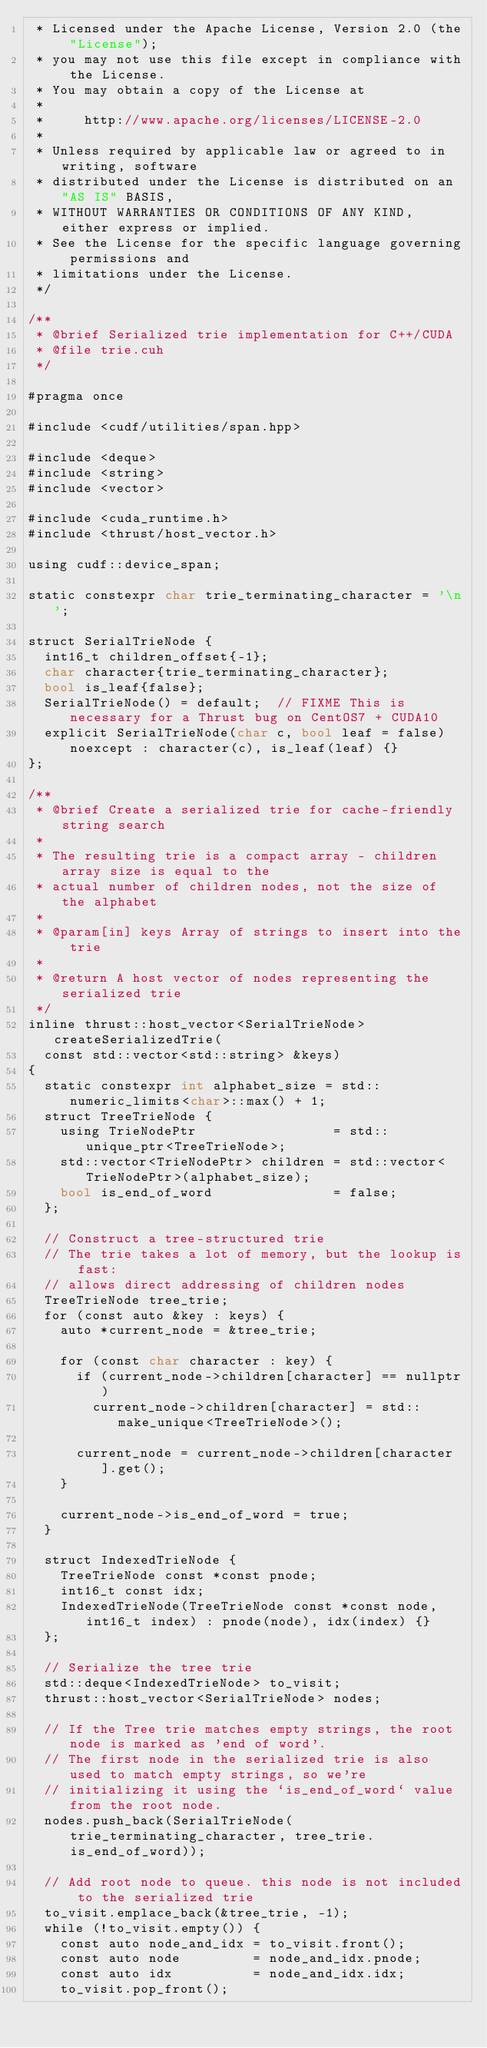Convert code to text. <code><loc_0><loc_0><loc_500><loc_500><_Cuda_> * Licensed under the Apache License, Version 2.0 (the "License");
 * you may not use this file except in compliance with the License.
 * You may obtain a copy of the License at
 *
 *     http://www.apache.org/licenses/LICENSE-2.0
 *
 * Unless required by applicable law or agreed to in writing, software
 * distributed under the License is distributed on an "AS IS" BASIS,
 * WITHOUT WARRANTIES OR CONDITIONS OF ANY KIND, either express or implied.
 * See the License for the specific language governing permissions and
 * limitations under the License.
 */

/**
 * @brief Serialized trie implementation for C++/CUDA
 * @file trie.cuh
 */

#pragma once

#include <cudf/utilities/span.hpp>

#include <deque>
#include <string>
#include <vector>

#include <cuda_runtime.h>
#include <thrust/host_vector.h>

using cudf::device_span;

static constexpr char trie_terminating_character = '\n';

struct SerialTrieNode {
  int16_t children_offset{-1};
  char character{trie_terminating_character};
  bool is_leaf{false};
  SerialTrieNode() = default;  // FIXME This is necessary for a Thrust bug on CentOS7 + CUDA10
  explicit SerialTrieNode(char c, bool leaf = false) noexcept : character(c), is_leaf(leaf) {}
};

/**
 * @brief Create a serialized trie for cache-friendly string search
 *
 * The resulting trie is a compact array - children array size is equal to the
 * actual number of children nodes, not the size of the alphabet
 *
 * @param[in] keys Array of strings to insert into the trie
 *
 * @return A host vector of nodes representing the serialized trie
 */
inline thrust::host_vector<SerialTrieNode> createSerializedTrie(
  const std::vector<std::string> &keys)
{
  static constexpr int alphabet_size = std::numeric_limits<char>::max() + 1;
  struct TreeTrieNode {
    using TrieNodePtr                 = std::unique_ptr<TreeTrieNode>;
    std::vector<TrieNodePtr> children = std::vector<TrieNodePtr>(alphabet_size);
    bool is_end_of_word               = false;
  };

  // Construct a tree-structured trie
  // The trie takes a lot of memory, but the lookup is fast:
  // allows direct addressing of children nodes
  TreeTrieNode tree_trie;
  for (const auto &key : keys) {
    auto *current_node = &tree_trie;

    for (const char character : key) {
      if (current_node->children[character] == nullptr)
        current_node->children[character] = std::make_unique<TreeTrieNode>();

      current_node = current_node->children[character].get();
    }

    current_node->is_end_of_word = true;
  }

  struct IndexedTrieNode {
    TreeTrieNode const *const pnode;
    int16_t const idx;
    IndexedTrieNode(TreeTrieNode const *const node, int16_t index) : pnode(node), idx(index) {}
  };

  // Serialize the tree trie
  std::deque<IndexedTrieNode> to_visit;
  thrust::host_vector<SerialTrieNode> nodes;

  // If the Tree trie matches empty strings, the root node is marked as 'end of word'.
  // The first node in the serialized trie is also used to match empty strings, so we're
  // initializing it using the `is_end_of_word` value from the root node.
  nodes.push_back(SerialTrieNode(trie_terminating_character, tree_trie.is_end_of_word));

  // Add root node to queue. this node is not included to the serialized trie
  to_visit.emplace_back(&tree_trie, -1);
  while (!to_visit.empty()) {
    const auto node_and_idx = to_visit.front();
    const auto node         = node_and_idx.pnode;
    const auto idx          = node_and_idx.idx;
    to_visit.pop_front();
</code> 